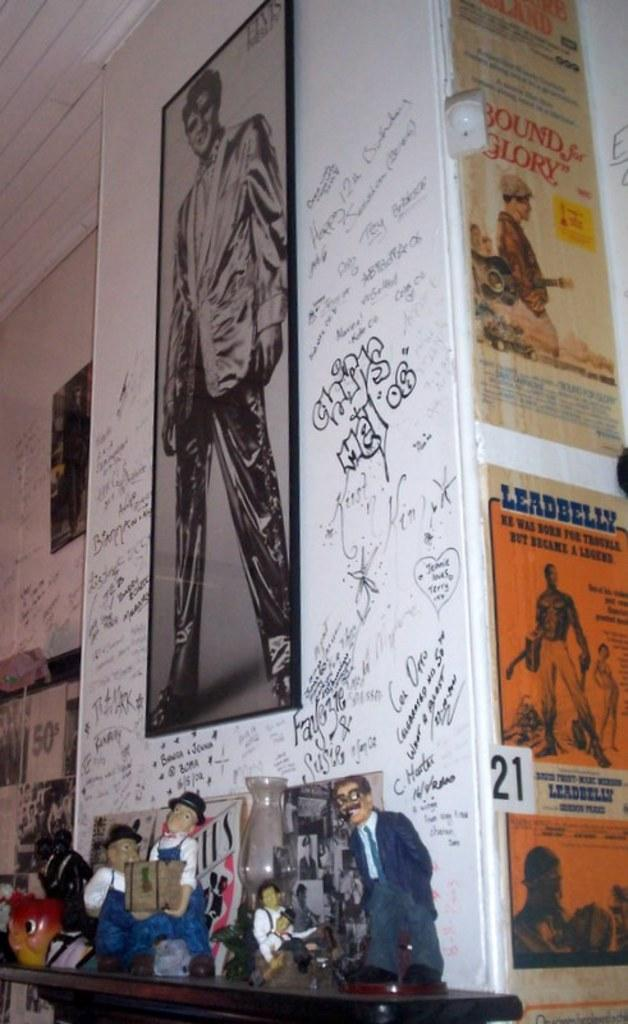<image>
Write a terse but informative summary of the picture. A picture of Elvis with a poster next to it reading Leadbelly 